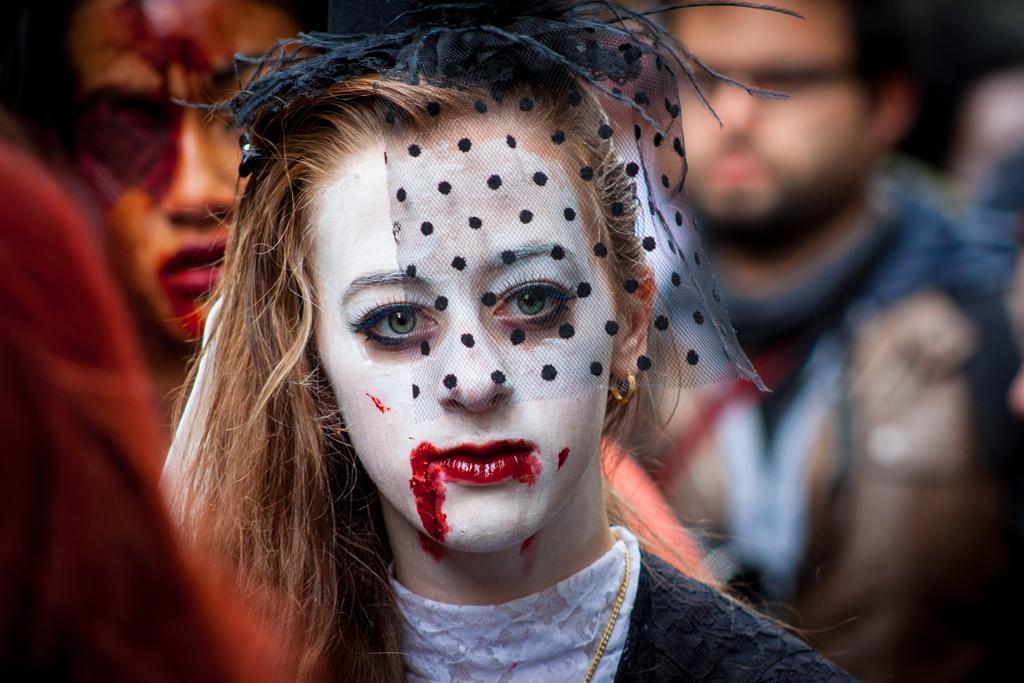Can you describe this image briefly? In front of the picture, we see the girl with Halloween makeup. Behind her, we see a man with Halloween makeup. In the background, we see a man is standing. This picture is blurred in the background. On the left side, we see the red color cloth. 